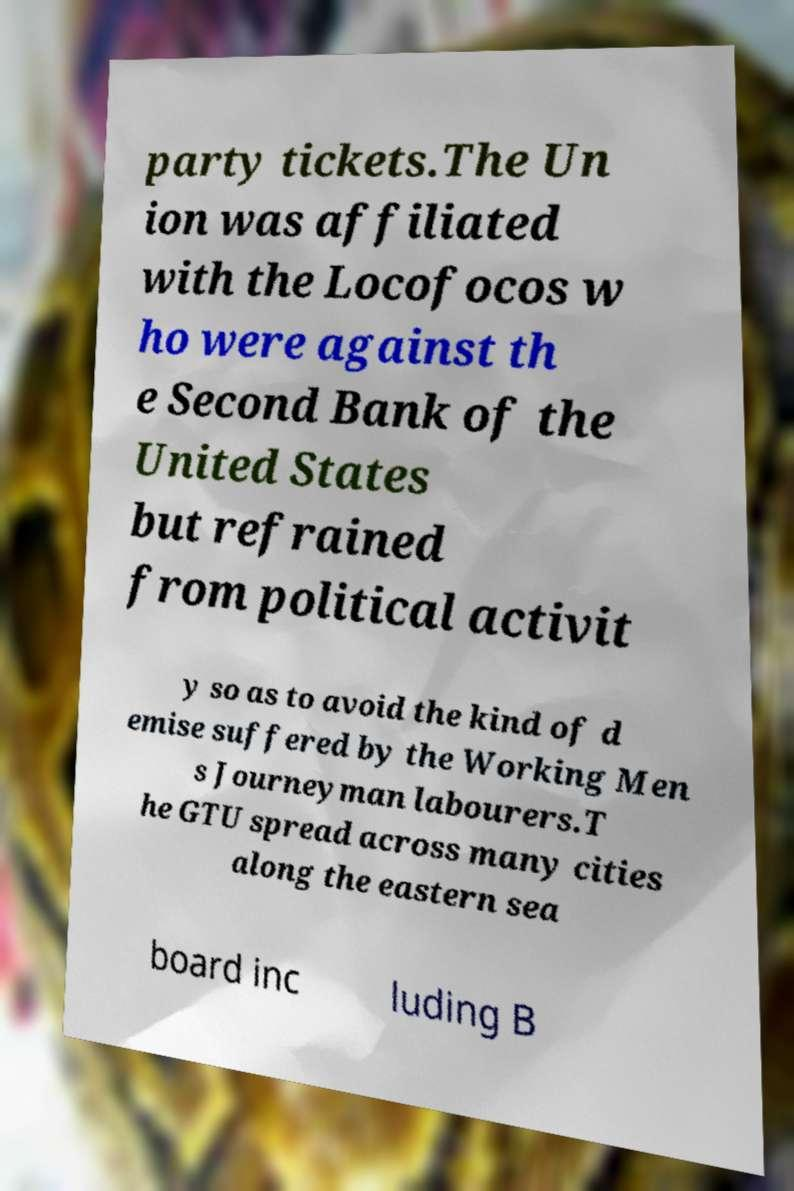For documentation purposes, I need the text within this image transcribed. Could you provide that? party tickets.The Un ion was affiliated with the Locofocos w ho were against th e Second Bank of the United States but refrained from political activit y so as to avoid the kind of d emise suffered by the Working Men s Journeyman labourers.T he GTU spread across many cities along the eastern sea board inc luding B 